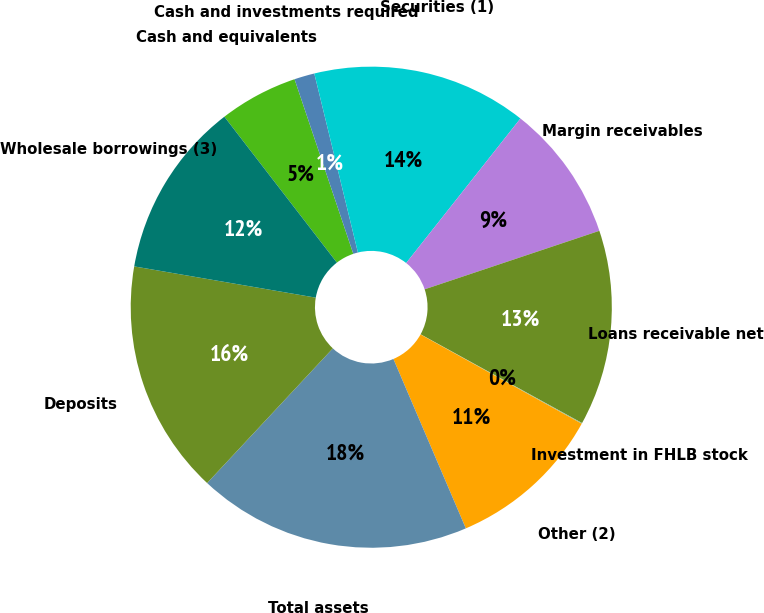Convert chart to OTSL. <chart><loc_0><loc_0><loc_500><loc_500><pie_chart><fcel>Cash and equivalents<fcel>Cash and investments required<fcel>Securities (1)<fcel>Margin receivables<fcel>Loans receivable net<fcel>Investment in FHLB stock<fcel>Other (2)<fcel>Total assets<fcel>Deposits<fcel>Wholesale borrowings (3)<nl><fcel>5.29%<fcel>1.36%<fcel>14.45%<fcel>9.21%<fcel>13.14%<fcel>0.05%<fcel>10.52%<fcel>18.38%<fcel>15.76%<fcel>11.83%<nl></chart> 